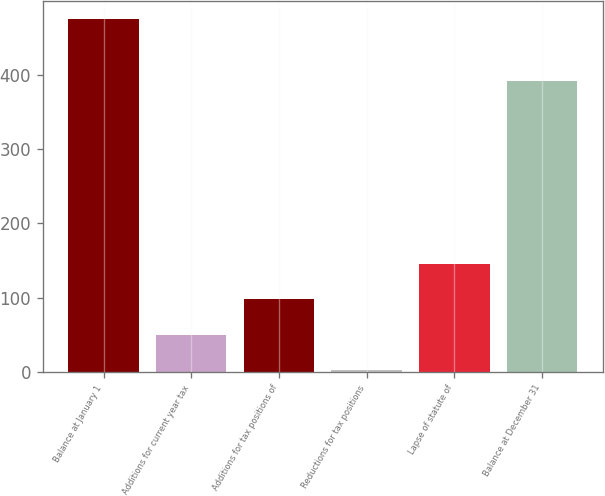Convert chart. <chart><loc_0><loc_0><loc_500><loc_500><bar_chart><fcel>Balance at January 1<fcel>Additions for current year tax<fcel>Additions for tax positions of<fcel>Reductions for tax positions<fcel>Lapse of statute of<fcel>Balance at December 31<nl><fcel>475<fcel>50.2<fcel>97.4<fcel>3<fcel>144.6<fcel>392<nl></chart> 